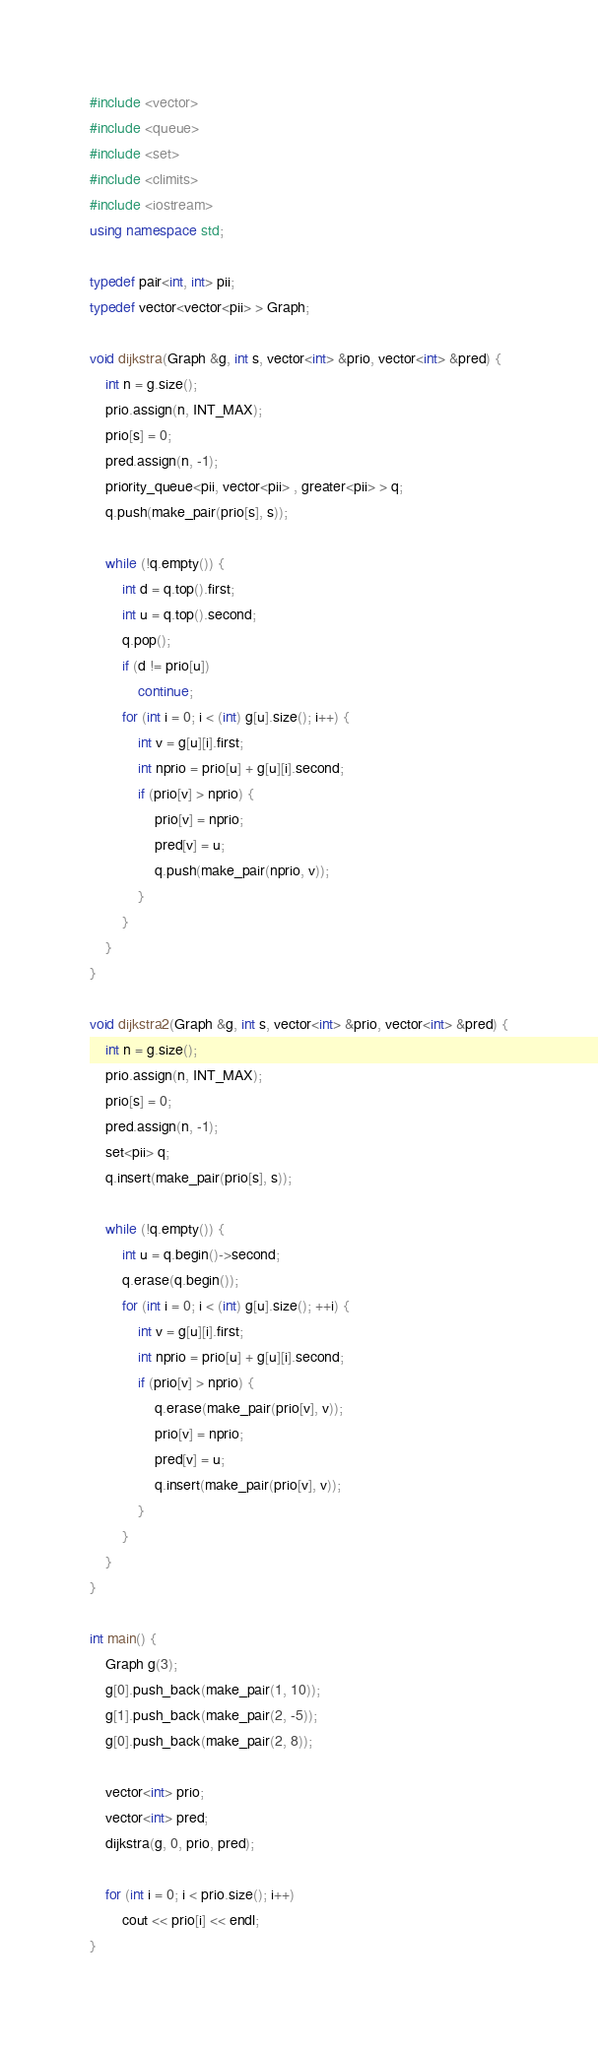Convert code to text. <code><loc_0><loc_0><loc_500><loc_500><_C++_>#include <vector>
#include <queue>
#include <set>
#include <climits>
#include <iostream>
using namespace std;

typedef pair<int, int> pii;
typedef vector<vector<pii> > Graph;

void dijkstra(Graph &g, int s, vector<int> &prio, vector<int> &pred) {
    int n = g.size();
    prio.assign(n, INT_MAX);
    prio[s] = 0;
    pred.assign(n, -1);
    priority_queue<pii, vector<pii> , greater<pii> > q;
    q.push(make_pair(prio[s], s));

    while (!q.empty()) {
        int d = q.top().first;
        int u = q.top().second;
        q.pop();
        if (d != prio[u])
            continue;
        for (int i = 0; i < (int) g[u].size(); i++) {
            int v = g[u][i].first;
            int nprio = prio[u] + g[u][i].second;
            if (prio[v] > nprio) {
                prio[v] = nprio;
                pred[v] = u;
                q.push(make_pair(nprio, v));
            }
        }
    }
}

void dijkstra2(Graph &g, int s, vector<int> &prio, vector<int> &pred) {
    int n = g.size();
    prio.assign(n, INT_MAX);
    prio[s] = 0;
    pred.assign(n, -1);
    set<pii> q;
    q.insert(make_pair(prio[s], s));

    while (!q.empty()) {
        int u = q.begin()->second;
        q.erase(q.begin());
        for (int i = 0; i < (int) g[u].size(); ++i) {
            int v = g[u][i].first;
            int nprio = prio[u] + g[u][i].second;
            if (prio[v] > nprio) {
                q.erase(make_pair(prio[v], v));
                prio[v] = nprio;
                pred[v] = u;
                q.insert(make_pair(prio[v], v));
            }
        }
    }
}

int main() {
    Graph g(3);
    g[0].push_back(make_pair(1, 10));
    g[1].push_back(make_pair(2, -5));
    g[0].push_back(make_pair(2, 8));

    vector<int> prio;
    vector<int> pred;
    dijkstra(g, 0, prio, pred);

    for (int i = 0; i < prio.size(); i++)
        cout << prio[i] << endl;
}
</code> 